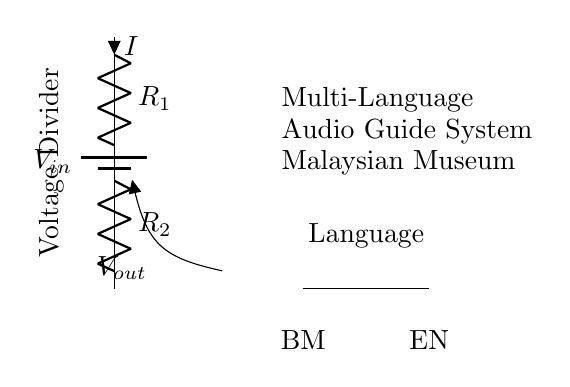What is the input voltage represented in the circuit? The input voltage is labeled as V-in, indicating where the power source connects to the circuit.
Answer: V-in What are the two resistors in the voltage divider? The two resistors in the voltage divider are labeled as R1 and R2, which are in series between the input voltage and ground.
Answer: R1 and R2 What is the output voltage represented by? The output voltage is marked as V-out, which is the voltage across R2 in the voltage divider configuration.
Answer: V-out What does the language switch allow for? The language switch allows for selection between two languages, which are labeled as BM (Bahasa Malaysia) and EN (English) on either side of the switch.
Answer: Language selection How does the voltage divider affect the audio guide? The voltage divider provides different output voltages that can be used to power the audio guide system at varying levels, suitable for the language chosen.
Answer: Varying output voltages What indicates the current direction in the circuit? The current direction is indicated by the arrow on the current label i, which shows the flow through resistor R1 downward into R2.
Answer: Arrow on the current label What key purpose does this circuit serve in the museum context? This circuit serves to power a multi-language audio guide system for visitors in the museum, allowing them to choose their preferred language.
Answer: Multi-language audio guide system 